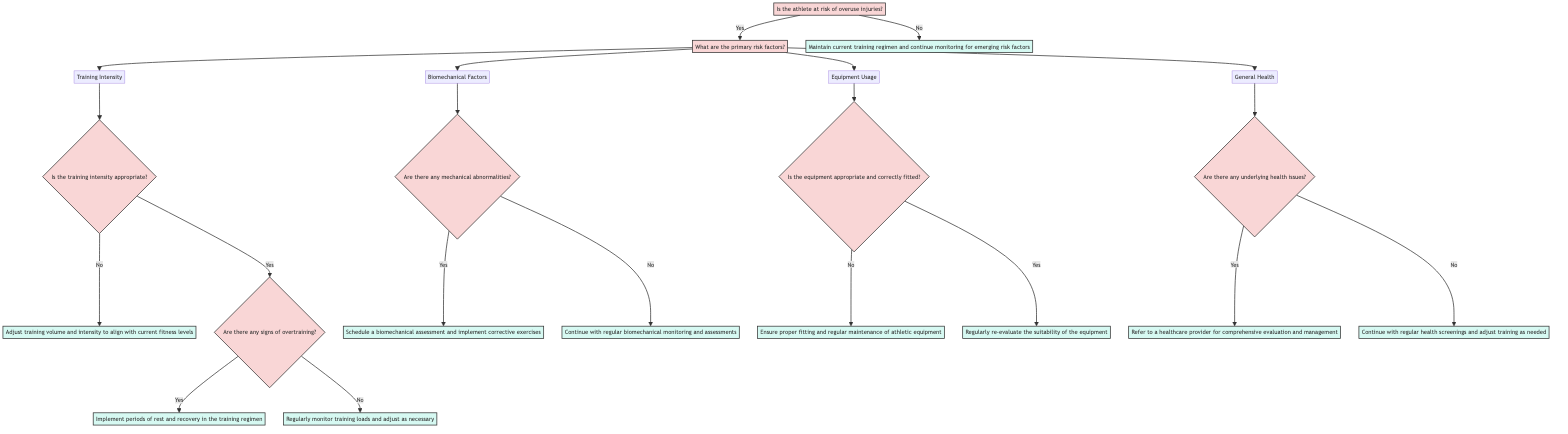What is the first question in the decision tree? The first question in the decision tree is found at the root node and it asks whether the athlete is at risk of overuse injuries.
Answer: Is the athlete at risk of overuse injuries? How many primary risk factors are listed in the decision tree? The decision tree lists four primary risk factors, which are Training Intensity, Biomechanical Factors, Equipment Usage, and General Health.
Answer: Four If the training intensity is appropriate, what is the next question to consider? If the training intensity is deemed appropriate, the next question to consider is whether there are any signs of overtraining. This can be found as the next node in the path after answering Yes to the training intensity question.
Answer: Are there any signs of overtraining? What recommendation is given if there are mechanical abnormalities? If there are mechanical abnormalities present, the recommendation is to schedule a biomechanical assessment and implement corrective exercises. This outcome is reached by following the path from the primary risk factor of Biomechanical Factors.
Answer: Schedule a biomechanical assessment and implement corrective exercises What action should be taken if there are underlying health issues? In the case of underlying health issues, the protocol is to refer the athlete to a healthcare provider for comprehensive evaluation and management. This recommendation is a direct output from the General Health node.
Answer: Refer to a healthcare provider for comprehensive evaluation and management What happens if the athlete is not at risk of overuse injuries? If the athlete is determined to not be at risk of overuse injuries, the recommendation is to maintain the current training regimen and continue monitoring for emerging risk factors. This can be found at the node that follows the No branch directly off the root.
Answer: Maintain current training regimen and continue monitoring for emerging risk factors What is the recommendation if the athlete has appropriate and fitted equipment? If the equipment is deemed appropriate and correctly fitted, the recommendation is to regularly re-evaluate the suitability of the equipment to ensure ongoing safety and performance. This is listed under the Equipment Usage risk factor.
Answer: Regularly re-evaluate the suitability of the equipment How does one approach the assessment of training intensity? To assess training intensity, one must first determine if it is appropriate. If it is not appropriate, it leads to a recommendation to adjust training volume and intensity. If it is appropriate, one must then check for signs of overtraining. This systematic approach is demonstrated in the decision tree.
Answer: Check if training intensity is appropriate 